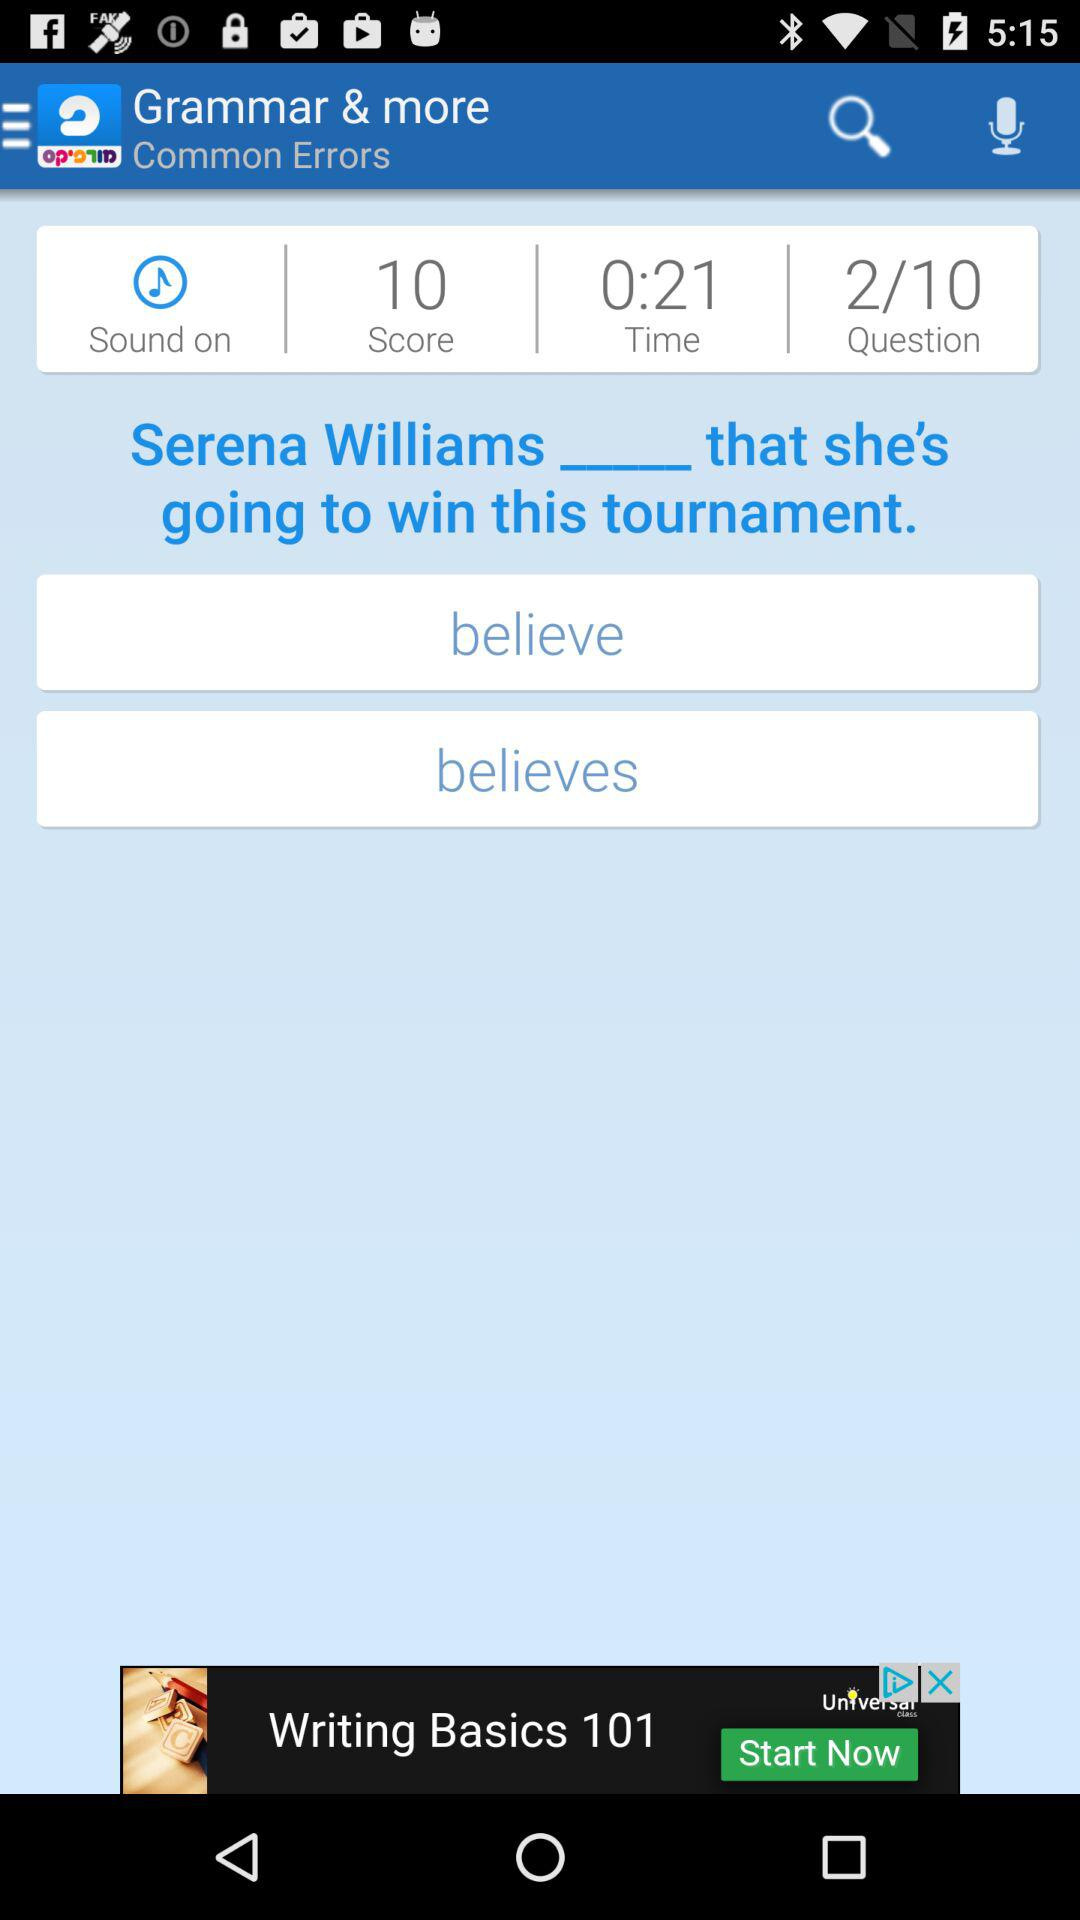How many questions have been answered? There are 2 questions that have been answered. 